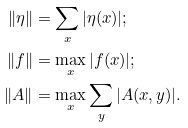Convert formula to latex. <formula><loc_0><loc_0><loc_500><loc_500>\| \eta \| & = \sum _ { x } | \eta ( x ) | ; \\ \| f \| & = \max _ { x } | f ( x ) | ; \\ \| A \| & = \max _ { x } \sum _ { y } | A ( x , y ) | .</formula> 